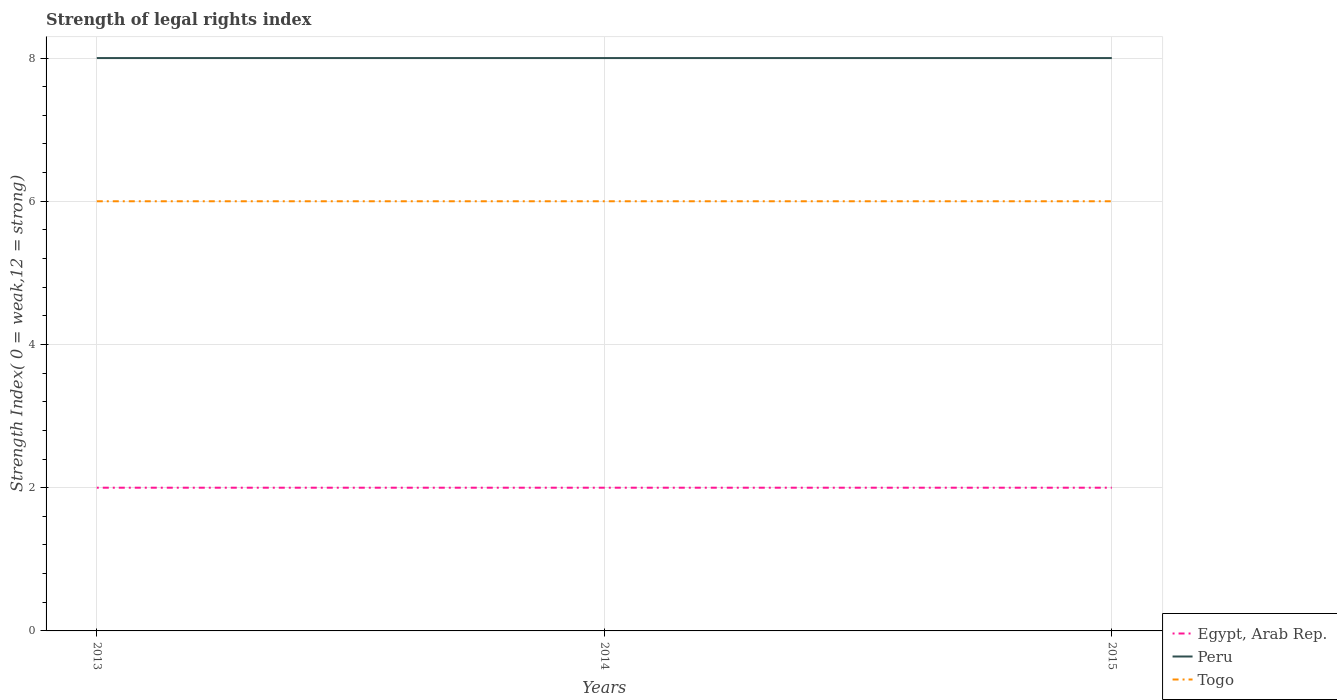How many different coloured lines are there?
Your answer should be compact. 3. Across all years, what is the maximum strength index in Egypt, Arab Rep.?
Provide a short and direct response. 2. What is the difference between the highest and the second highest strength index in Togo?
Offer a very short reply. 0. What is the difference between the highest and the lowest strength index in Togo?
Give a very brief answer. 0. Is the strength index in Egypt, Arab Rep. strictly greater than the strength index in Peru over the years?
Your answer should be very brief. Yes. How many lines are there?
Provide a short and direct response. 3. Does the graph contain any zero values?
Make the answer very short. No. Where does the legend appear in the graph?
Your response must be concise. Bottom right. How are the legend labels stacked?
Offer a very short reply. Vertical. What is the title of the graph?
Keep it short and to the point. Strength of legal rights index. Does "Australia" appear as one of the legend labels in the graph?
Your answer should be compact. No. What is the label or title of the X-axis?
Your answer should be very brief. Years. What is the label or title of the Y-axis?
Your answer should be very brief. Strength Index( 0 = weak,12 = strong). What is the Strength Index( 0 = weak,12 = strong) of Togo in 2013?
Your answer should be very brief. 6. What is the Strength Index( 0 = weak,12 = strong) in Peru in 2014?
Your answer should be very brief. 8. What is the Strength Index( 0 = weak,12 = strong) of Peru in 2015?
Provide a succinct answer. 8. What is the Strength Index( 0 = weak,12 = strong) in Togo in 2015?
Your answer should be compact. 6. Across all years, what is the maximum Strength Index( 0 = weak,12 = strong) in Togo?
Your response must be concise. 6. Across all years, what is the minimum Strength Index( 0 = weak,12 = strong) of Egypt, Arab Rep.?
Your answer should be very brief. 2. What is the total Strength Index( 0 = weak,12 = strong) of Peru in the graph?
Provide a short and direct response. 24. What is the total Strength Index( 0 = weak,12 = strong) in Togo in the graph?
Offer a terse response. 18. What is the difference between the Strength Index( 0 = weak,12 = strong) of Peru in 2013 and that in 2014?
Make the answer very short. 0. What is the difference between the Strength Index( 0 = weak,12 = strong) of Togo in 2013 and that in 2014?
Your response must be concise. 0. What is the difference between the Strength Index( 0 = weak,12 = strong) in Peru in 2013 and that in 2015?
Offer a terse response. 0. What is the difference between the Strength Index( 0 = weak,12 = strong) of Peru in 2014 and that in 2015?
Ensure brevity in your answer.  0. What is the difference between the Strength Index( 0 = weak,12 = strong) in Togo in 2014 and that in 2015?
Your response must be concise. 0. What is the difference between the Strength Index( 0 = weak,12 = strong) of Egypt, Arab Rep. in 2013 and the Strength Index( 0 = weak,12 = strong) of Peru in 2014?
Your response must be concise. -6. What is the difference between the Strength Index( 0 = weak,12 = strong) of Peru in 2013 and the Strength Index( 0 = weak,12 = strong) of Togo in 2014?
Your answer should be compact. 2. What is the difference between the Strength Index( 0 = weak,12 = strong) of Egypt, Arab Rep. in 2013 and the Strength Index( 0 = weak,12 = strong) of Peru in 2015?
Your answer should be very brief. -6. What is the difference between the Strength Index( 0 = weak,12 = strong) of Peru in 2013 and the Strength Index( 0 = weak,12 = strong) of Togo in 2015?
Your answer should be compact. 2. What is the difference between the Strength Index( 0 = weak,12 = strong) in Egypt, Arab Rep. in 2014 and the Strength Index( 0 = weak,12 = strong) in Togo in 2015?
Make the answer very short. -4. What is the difference between the Strength Index( 0 = weak,12 = strong) of Peru in 2014 and the Strength Index( 0 = weak,12 = strong) of Togo in 2015?
Provide a succinct answer. 2. In the year 2013, what is the difference between the Strength Index( 0 = weak,12 = strong) of Peru and Strength Index( 0 = weak,12 = strong) of Togo?
Ensure brevity in your answer.  2. In the year 2014, what is the difference between the Strength Index( 0 = weak,12 = strong) of Egypt, Arab Rep. and Strength Index( 0 = weak,12 = strong) of Peru?
Keep it short and to the point. -6. In the year 2015, what is the difference between the Strength Index( 0 = weak,12 = strong) of Egypt, Arab Rep. and Strength Index( 0 = weak,12 = strong) of Peru?
Provide a succinct answer. -6. In the year 2015, what is the difference between the Strength Index( 0 = weak,12 = strong) in Egypt, Arab Rep. and Strength Index( 0 = weak,12 = strong) in Togo?
Your answer should be very brief. -4. What is the ratio of the Strength Index( 0 = weak,12 = strong) in Egypt, Arab Rep. in 2013 to that in 2014?
Your answer should be compact. 1. What is the ratio of the Strength Index( 0 = weak,12 = strong) of Peru in 2013 to that in 2014?
Make the answer very short. 1. What is the ratio of the Strength Index( 0 = weak,12 = strong) in Togo in 2013 to that in 2014?
Offer a terse response. 1. What is the ratio of the Strength Index( 0 = weak,12 = strong) of Peru in 2013 to that in 2015?
Provide a succinct answer. 1. What is the ratio of the Strength Index( 0 = weak,12 = strong) of Egypt, Arab Rep. in 2014 to that in 2015?
Your answer should be compact. 1. What is the difference between the highest and the second highest Strength Index( 0 = weak,12 = strong) of Egypt, Arab Rep.?
Provide a succinct answer. 0. What is the difference between the highest and the second highest Strength Index( 0 = weak,12 = strong) in Peru?
Offer a terse response. 0. What is the difference between the highest and the second highest Strength Index( 0 = weak,12 = strong) of Togo?
Offer a terse response. 0. What is the difference between the highest and the lowest Strength Index( 0 = weak,12 = strong) of Egypt, Arab Rep.?
Offer a terse response. 0. What is the difference between the highest and the lowest Strength Index( 0 = weak,12 = strong) in Peru?
Your response must be concise. 0. What is the difference between the highest and the lowest Strength Index( 0 = weak,12 = strong) of Togo?
Your answer should be very brief. 0. 